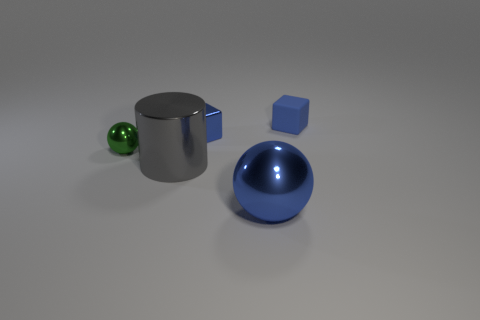What number of other tiny things have the same color as the rubber thing?
Make the answer very short. 1. There is a blue thing that is right of the ball in front of the large shiny cylinder; what is it made of?
Ensure brevity in your answer.  Rubber. The gray object is what size?
Provide a short and direct response. Large. How many blue rubber blocks have the same size as the metal block?
Your answer should be compact. 1. How many other small things have the same shape as the tiny blue matte thing?
Give a very brief answer. 1. Are there an equal number of large gray shiny cylinders on the left side of the large gray thing and big metal cylinders?
Your answer should be very brief. No. What is the shape of the blue thing that is the same size as the gray shiny cylinder?
Offer a very short reply. Sphere. Is there another gray thing of the same shape as the tiny rubber object?
Your answer should be compact. No. There is a blue metallic thing in front of the large cylinder that is in front of the tiny blue metallic thing; are there any small blue things in front of it?
Give a very brief answer. No. Are there more tiny green spheres to the left of the green metallic object than small blue matte objects in front of the tiny blue rubber block?
Ensure brevity in your answer.  No. 